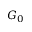<formula> <loc_0><loc_0><loc_500><loc_500>G _ { 0 }</formula> 